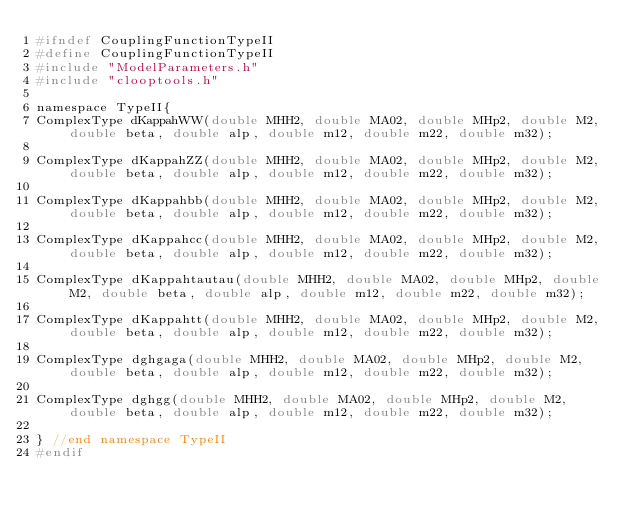<code> <loc_0><loc_0><loc_500><loc_500><_C_>#ifndef CouplingFunctionTypeII
#define CouplingFunctionTypeII
#include "ModelParameters.h"
#include "clooptools.h"

namespace TypeII{
ComplexType dKappahWW(double MHH2, double MA02, double MHp2, double M2, double beta, double alp, double m12, double m22, double m32);

ComplexType dKappahZZ(double MHH2, double MA02, double MHp2, double M2, double beta, double alp, double m12, double m22, double m32);

ComplexType dKappahbb(double MHH2, double MA02, double MHp2, double M2, double beta, double alp, double m12, double m22, double m32);

ComplexType dKappahcc(double MHH2, double MA02, double MHp2, double M2, double beta, double alp, double m12, double m22, double m32);

ComplexType dKappahtautau(double MHH2, double MA02, double MHp2, double M2, double beta, double alp, double m12, double m22, double m32);

ComplexType dKappahtt(double MHH2, double MA02, double MHp2, double M2, double beta, double alp, double m12, double m22, double m32);

ComplexType dghgaga(double MHH2, double MA02, double MHp2, double M2, double beta, double alp, double m12, double m22, double m32);

ComplexType dghgg(double MHH2, double MA02, double MHp2, double M2, double beta, double alp, double m12, double m22, double m32);

} //end namespace TypeII
#endif
</code> 